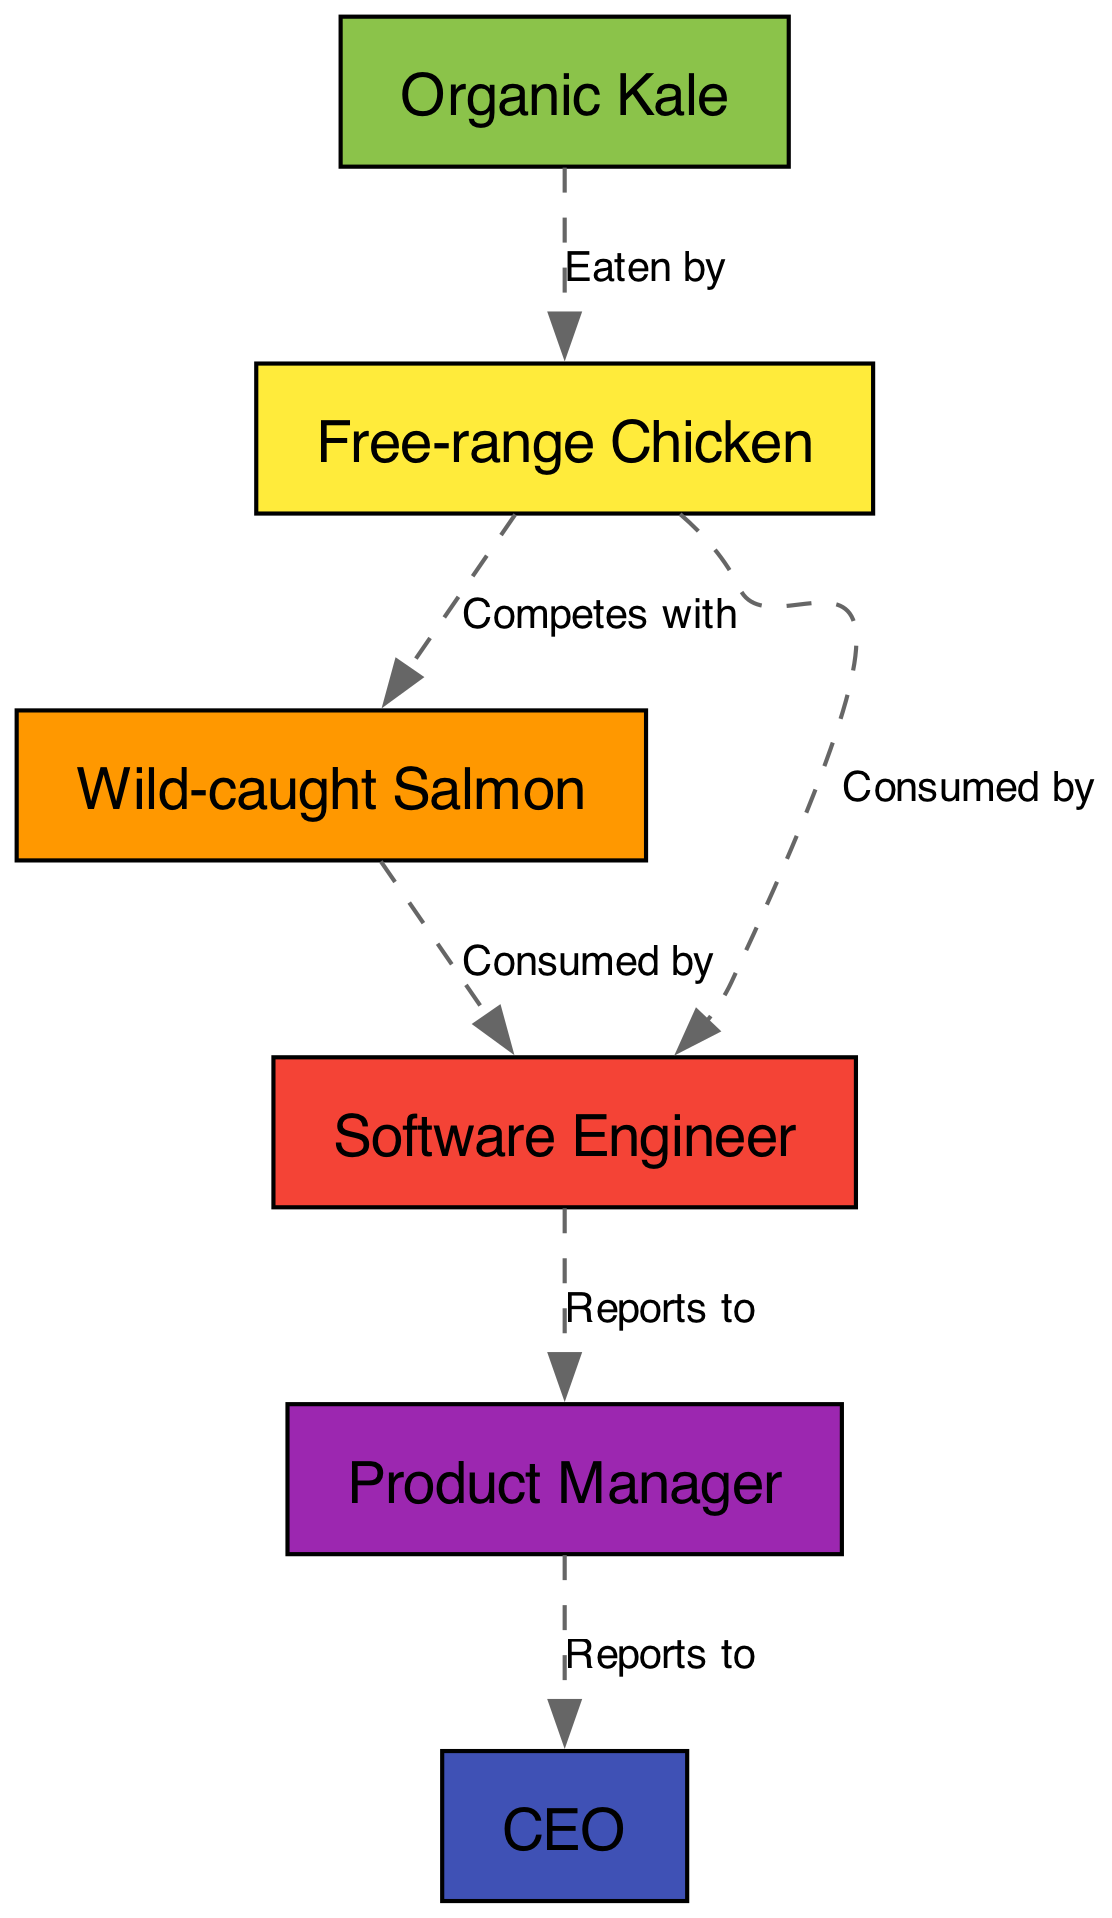What is the primary producer in this food chain? The diagram lists "Organic Kale" as the only entity classified as a primary producer, which means it is the starting point for the food chain.
Answer: Organic Kale Who consumes the free-range chicken? According to the diagram, both the "Software Engineer" and "Wild-caught Salmon" have direct relationships indicating they consume or interact with "Free-range Chicken." However, the question requires a direct answer from the elements; thus, the specific consumer listed is the software engineer.
Answer: Software Engineer How many total nodes are present in the diagram? The diagram consists of 6 distinct elements listed as nodes: Organic Kale, Free-range Chicken, Wild-caught Salmon, Software Engineer, Product Manager, and CEO. Therefore, the total number of nodes is 6.
Answer: 6 Which relationship indicates competition among consumers? The relationship labeled "Competes with" specifically connects the "Free-range Chicken" and the "Wild-caught Salmon," which indicates a competitive relationship among these consumers concerning their food resources.
Answer: Competes with What level is the CEO in the food chain? The CEO is classified as an "Apex Consumer," which is the highest level in the food chain hierarchy as represented in the diagram.
Answer: Apex Consumer Which element reports to the product manager? Referring to the relationships in the diagram, the "CEO" is indicated to report to the "Product Manager," showcasing the hierarchy where the Product Manager is immediately above the CEO.
Answer: CEO What color represents the secondary consumer in the diagram? The color scheme assigns "Wild-caught Salmon," the secondary consumer, a distinct color. In the diagram, it is filled with the color #FF9800, which stands for the secondary consumer category.
Answer: #FF9800 